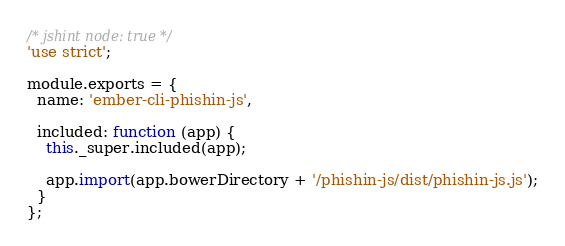<code> <loc_0><loc_0><loc_500><loc_500><_JavaScript_>/* jshint node: true */
'use strict';

module.exports = {
  name: 'ember-cli-phishin-js',

  included: function (app) {
    this._super.included(app);

    app.import(app.bowerDirectory + '/phishin-js/dist/phishin-js.js');
  }
};
</code> 